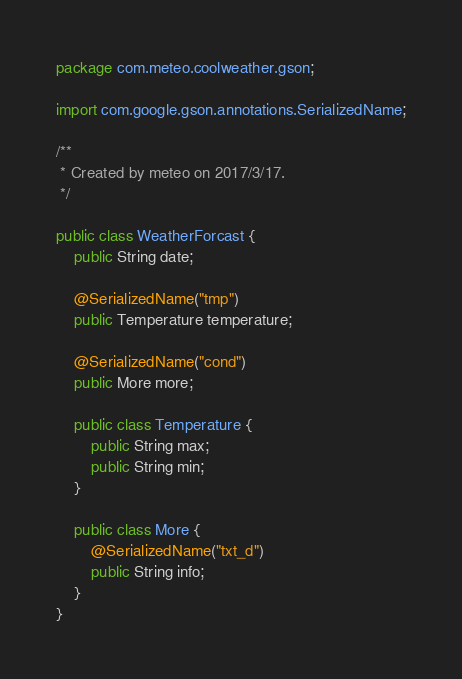Convert code to text. <code><loc_0><loc_0><loc_500><loc_500><_Java_>package com.meteo.coolweather.gson;

import com.google.gson.annotations.SerializedName;

/**
 * Created by meteo on 2017/3/17.
 */

public class WeatherForcast {
    public String date;

    @SerializedName("tmp")
    public Temperature temperature;

    @SerializedName("cond")
    public More more;

    public class Temperature {
        public String max;
        public String min;
    }

    public class More {
        @SerializedName("txt_d")
        public String info;
    }
}
</code> 